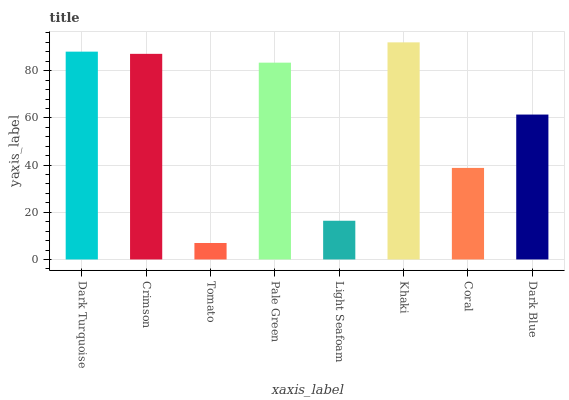Is Tomato the minimum?
Answer yes or no. Yes. Is Khaki the maximum?
Answer yes or no. Yes. Is Crimson the minimum?
Answer yes or no. No. Is Crimson the maximum?
Answer yes or no. No. Is Dark Turquoise greater than Crimson?
Answer yes or no. Yes. Is Crimson less than Dark Turquoise?
Answer yes or no. Yes. Is Crimson greater than Dark Turquoise?
Answer yes or no. No. Is Dark Turquoise less than Crimson?
Answer yes or no. No. Is Pale Green the high median?
Answer yes or no. Yes. Is Dark Blue the low median?
Answer yes or no. Yes. Is Light Seafoam the high median?
Answer yes or no. No. Is Tomato the low median?
Answer yes or no. No. 